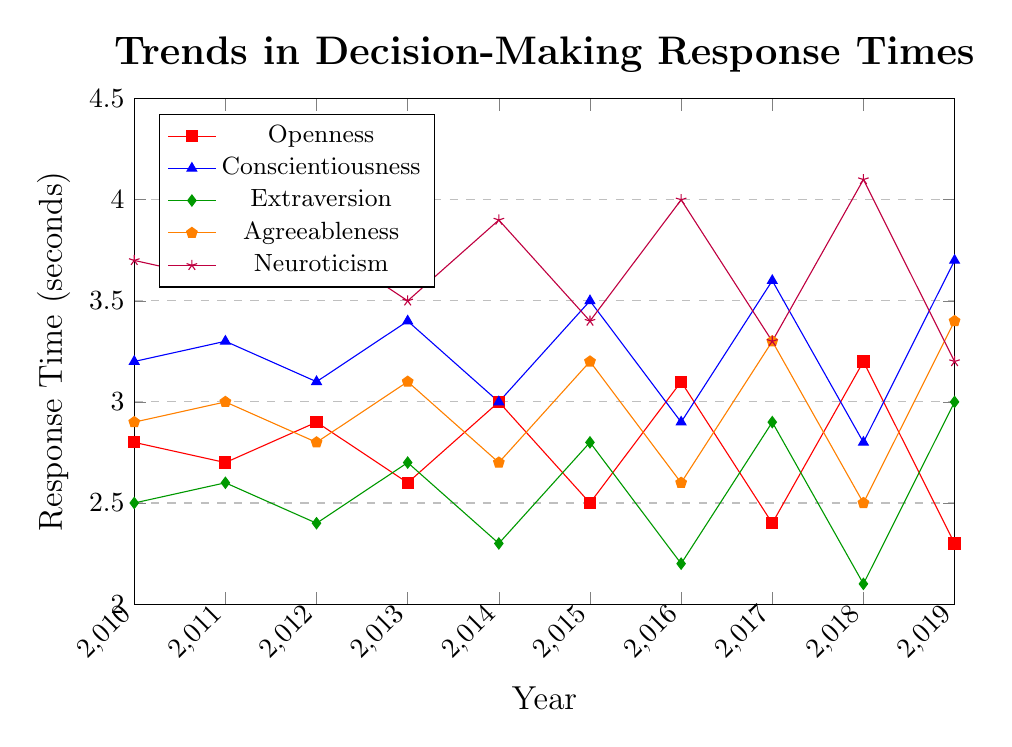What is the trend of response times for the Neuroticism trait from 2010 to 2019? To find the trend, we look at the plotted line for Neuroticism (purple, marked by stars). We observe that the response time decreases overall from 2010 (3.7) to 2019 (3.2) with some fluctuations along the way.
Answer: Decreasing with fluctuations Which personality type had the highest response time in 2016? Identify the points for 2016 on the x-axis and compare the response times of the different personality types. Neuroticism has the highest value at 4.0 seconds.
Answer: Neuroticism What was the difference in response time between Conscientiousness and Extraversion in 2019? Locate the response times for 2019: Conscientiousness is at 3.7 and Extraversion is at 3.0. Subtract Extraversion from Conscientiousness: 3.7 - 3.0 = 0.7 seconds.
Answer: 0.7 seconds Which personality traits show an increasing trend from 2018 to 2019? Compare the two years by looking at the values of all personality traits: Openness (3.2 to 2.3, decreasing), Conscientiousness (2.8 to 3.7, increasing), Extraversion (2.1 to 3.0, increasing), Agreeableness (2.5 to 3.4, increasing), and Neuroticism (4.1 to 3.2, decreasing).
Answer: Conscientiousness, Extraversion, Agreeableness What is the most consistent trend shown by Conscientiousness from 2010 to 2019? Assess all the plotted points for Conscientiousness (blue, marked by triangles): 2010 (3.2), 2011 (3.3), 2012 (3.1), 2013 (3.4), 2014 (3.0), 2015 (3.5), 2016 (2.9), 2017 (3.6), 2018 (2.8), and 2019 (3.7). The trait fluctuates but shows an overall increasing trend.
Answer: Increasing trend How does the response time for Agreeableness in 2012 compare to that in 2018? Identify the response times for Agreeableness in 2012 and 2018: 2.8 and 2.5, respectively. 2012 has a higher value than 2018.
Answer: Higher in 2012 Calculate the average response time for Openness over the 10-year period. Sum all the response times for Openness and divide by 10: (2.8 + 2.7 + 2.9 + 2.6 + 3.0 + 2.5 + 3.1 + 2.4 + 3.2 + 2.3) / 10 = 27.5 / 10 = 2.75 seconds.
Answer: 2.75 seconds Which trait has the lowest response time in 2014, and what is that response time? Find the minimum value for the year 2014 among all traits. Extraversion has the lowest value at 2.3 seconds.
Answer: Extraversion, 2.3 seconds Determine the average response time for all traits in the year 2015. Average the response times of all five traits in 2015: (2.5 + 3.5 + 2.8 + 3.2 + 3.4) / 5 = 15.4 / 5 = 3.08 seconds.
Answer: 3.08 seconds What is the 3-year trend for Extraversion from 2016 to 2019? Examine the values for Extraversion in 2016 (2.2), 2017 (2.9), 2018 (2.1), and 2019 (3.0): the trend is decreasing from 2016 to 2018, and then increasing from 2018 to 2019.
Answer: Decrease then increase 